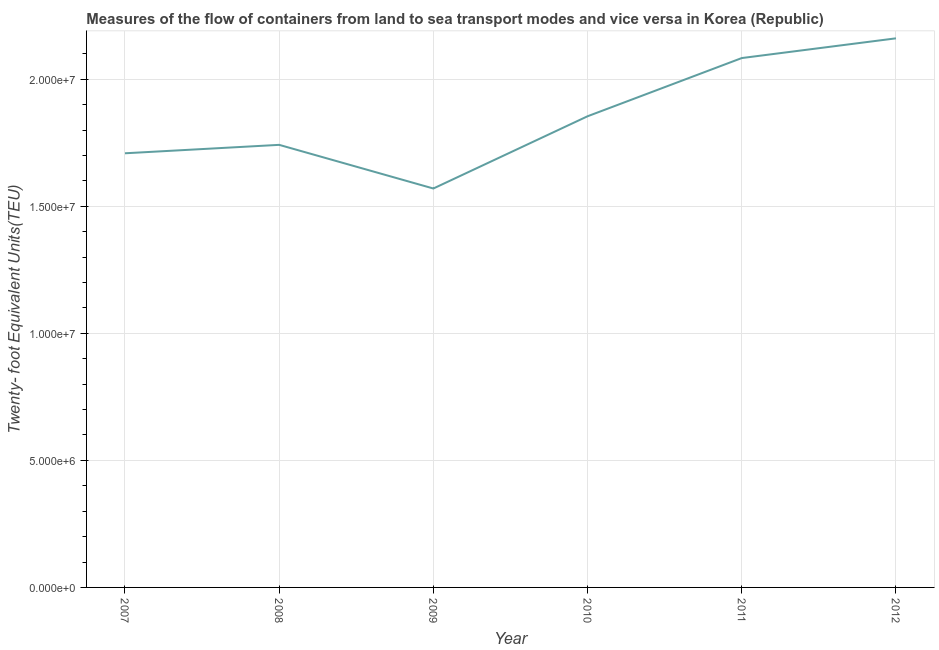What is the container port traffic in 2008?
Ensure brevity in your answer.  1.74e+07. Across all years, what is the maximum container port traffic?
Your response must be concise. 2.16e+07. Across all years, what is the minimum container port traffic?
Your answer should be very brief. 1.57e+07. In which year was the container port traffic maximum?
Provide a short and direct response. 2012. In which year was the container port traffic minimum?
Offer a terse response. 2009. What is the sum of the container port traffic?
Provide a succinct answer. 1.11e+08. What is the difference between the container port traffic in 2009 and 2010?
Your response must be concise. -2.84e+06. What is the average container port traffic per year?
Offer a terse response. 1.85e+07. What is the median container port traffic?
Provide a succinct answer. 1.80e+07. In how many years, is the container port traffic greater than 1000000 TEU?
Offer a very short reply. 6. Do a majority of the years between 2009 and 2011 (inclusive) have container port traffic greater than 17000000 TEU?
Ensure brevity in your answer.  Yes. What is the ratio of the container port traffic in 2007 to that in 2009?
Your response must be concise. 1.09. Is the container port traffic in 2007 less than that in 2011?
Provide a succinct answer. Yes. Is the difference between the container port traffic in 2010 and 2012 greater than the difference between any two years?
Keep it short and to the point. No. What is the difference between the highest and the second highest container port traffic?
Provide a succinct answer. 7.76e+05. Is the sum of the container port traffic in 2009 and 2010 greater than the maximum container port traffic across all years?
Make the answer very short. Yes. What is the difference between the highest and the lowest container port traffic?
Provide a short and direct response. 5.91e+06. How many years are there in the graph?
Provide a short and direct response. 6. What is the difference between two consecutive major ticks on the Y-axis?
Keep it short and to the point. 5.00e+06. Does the graph contain grids?
Make the answer very short. Yes. What is the title of the graph?
Your answer should be compact. Measures of the flow of containers from land to sea transport modes and vice versa in Korea (Republic). What is the label or title of the Y-axis?
Offer a terse response. Twenty- foot Equivalent Units(TEU). What is the Twenty- foot Equivalent Units(TEU) in 2007?
Your response must be concise. 1.71e+07. What is the Twenty- foot Equivalent Units(TEU) in 2008?
Ensure brevity in your answer.  1.74e+07. What is the Twenty- foot Equivalent Units(TEU) in 2009?
Offer a very short reply. 1.57e+07. What is the Twenty- foot Equivalent Units(TEU) of 2010?
Your response must be concise. 1.85e+07. What is the Twenty- foot Equivalent Units(TEU) in 2011?
Give a very brief answer. 2.08e+07. What is the Twenty- foot Equivalent Units(TEU) of 2012?
Offer a terse response. 2.16e+07. What is the difference between the Twenty- foot Equivalent Units(TEU) in 2007 and 2008?
Offer a very short reply. -3.32e+05. What is the difference between the Twenty- foot Equivalent Units(TEU) in 2007 and 2009?
Offer a very short reply. 1.39e+06. What is the difference between the Twenty- foot Equivalent Units(TEU) in 2007 and 2010?
Provide a succinct answer. -1.46e+06. What is the difference between the Twenty- foot Equivalent Units(TEU) in 2007 and 2011?
Offer a very short reply. -3.75e+06. What is the difference between the Twenty- foot Equivalent Units(TEU) in 2007 and 2012?
Offer a terse response. -4.52e+06. What is the difference between the Twenty- foot Equivalent Units(TEU) in 2008 and 2009?
Offer a terse response. 1.72e+06. What is the difference between the Twenty- foot Equivalent Units(TEU) in 2008 and 2010?
Give a very brief answer. -1.13e+06. What is the difference between the Twenty- foot Equivalent Units(TEU) in 2008 and 2011?
Provide a succinct answer. -3.42e+06. What is the difference between the Twenty- foot Equivalent Units(TEU) in 2008 and 2012?
Provide a short and direct response. -4.19e+06. What is the difference between the Twenty- foot Equivalent Units(TEU) in 2009 and 2010?
Keep it short and to the point. -2.84e+06. What is the difference between the Twenty- foot Equivalent Units(TEU) in 2009 and 2011?
Your answer should be compact. -5.13e+06. What is the difference between the Twenty- foot Equivalent Units(TEU) in 2009 and 2012?
Your answer should be compact. -5.91e+06. What is the difference between the Twenty- foot Equivalent Units(TEU) in 2010 and 2011?
Offer a terse response. -2.29e+06. What is the difference between the Twenty- foot Equivalent Units(TEU) in 2010 and 2012?
Offer a terse response. -3.07e+06. What is the difference between the Twenty- foot Equivalent Units(TEU) in 2011 and 2012?
Offer a terse response. -7.76e+05. What is the ratio of the Twenty- foot Equivalent Units(TEU) in 2007 to that in 2008?
Your answer should be compact. 0.98. What is the ratio of the Twenty- foot Equivalent Units(TEU) in 2007 to that in 2009?
Your answer should be very brief. 1.09. What is the ratio of the Twenty- foot Equivalent Units(TEU) in 2007 to that in 2010?
Provide a short and direct response. 0.92. What is the ratio of the Twenty- foot Equivalent Units(TEU) in 2007 to that in 2011?
Your answer should be very brief. 0.82. What is the ratio of the Twenty- foot Equivalent Units(TEU) in 2007 to that in 2012?
Your answer should be very brief. 0.79. What is the ratio of the Twenty- foot Equivalent Units(TEU) in 2008 to that in 2009?
Give a very brief answer. 1.11. What is the ratio of the Twenty- foot Equivalent Units(TEU) in 2008 to that in 2010?
Keep it short and to the point. 0.94. What is the ratio of the Twenty- foot Equivalent Units(TEU) in 2008 to that in 2011?
Ensure brevity in your answer.  0.84. What is the ratio of the Twenty- foot Equivalent Units(TEU) in 2008 to that in 2012?
Make the answer very short. 0.81. What is the ratio of the Twenty- foot Equivalent Units(TEU) in 2009 to that in 2010?
Provide a succinct answer. 0.85. What is the ratio of the Twenty- foot Equivalent Units(TEU) in 2009 to that in 2011?
Give a very brief answer. 0.75. What is the ratio of the Twenty- foot Equivalent Units(TEU) in 2009 to that in 2012?
Your answer should be very brief. 0.73. What is the ratio of the Twenty- foot Equivalent Units(TEU) in 2010 to that in 2011?
Provide a short and direct response. 0.89. What is the ratio of the Twenty- foot Equivalent Units(TEU) in 2010 to that in 2012?
Make the answer very short. 0.86. 